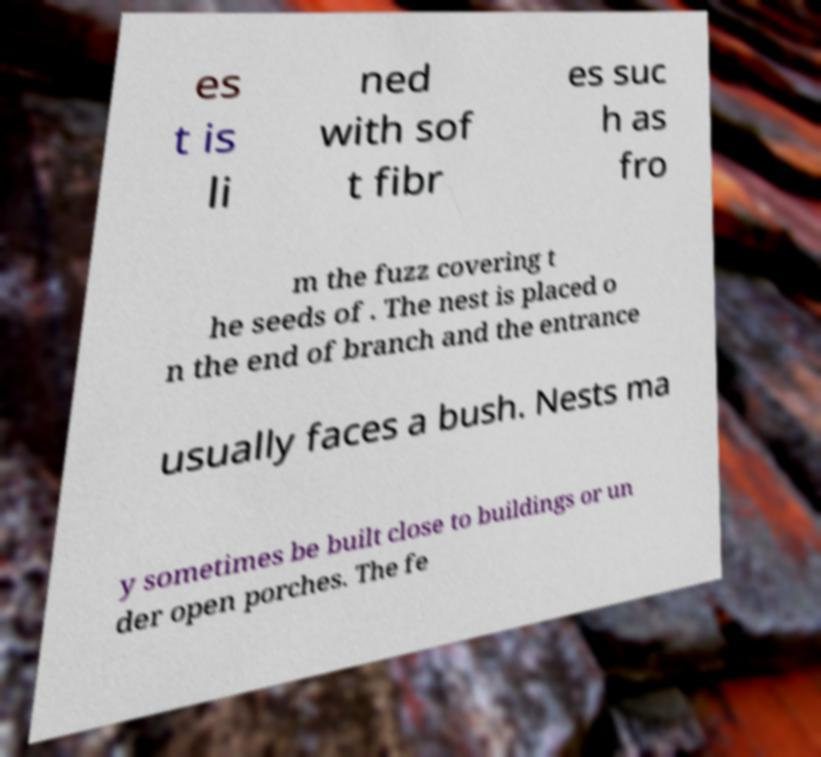Please read and relay the text visible in this image. What does it say? es t is li ned with sof t fibr es suc h as fro m the fuzz covering t he seeds of . The nest is placed o n the end of branch and the entrance usually faces a bush. Nests ma y sometimes be built close to buildings or un der open porches. The fe 